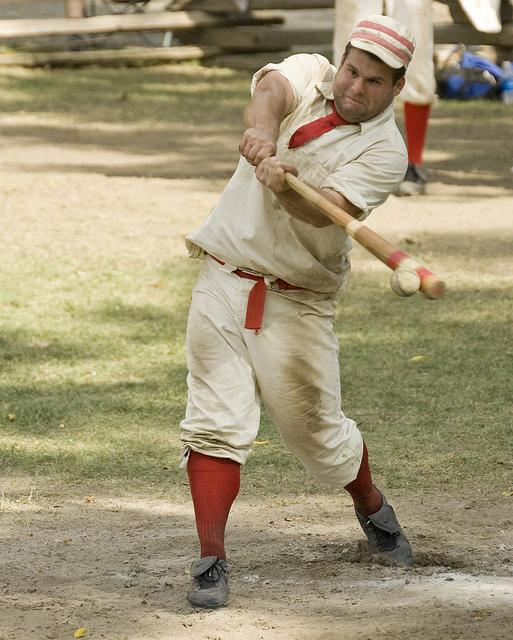Which country headquarters the brand company of this man's shoes? usa 